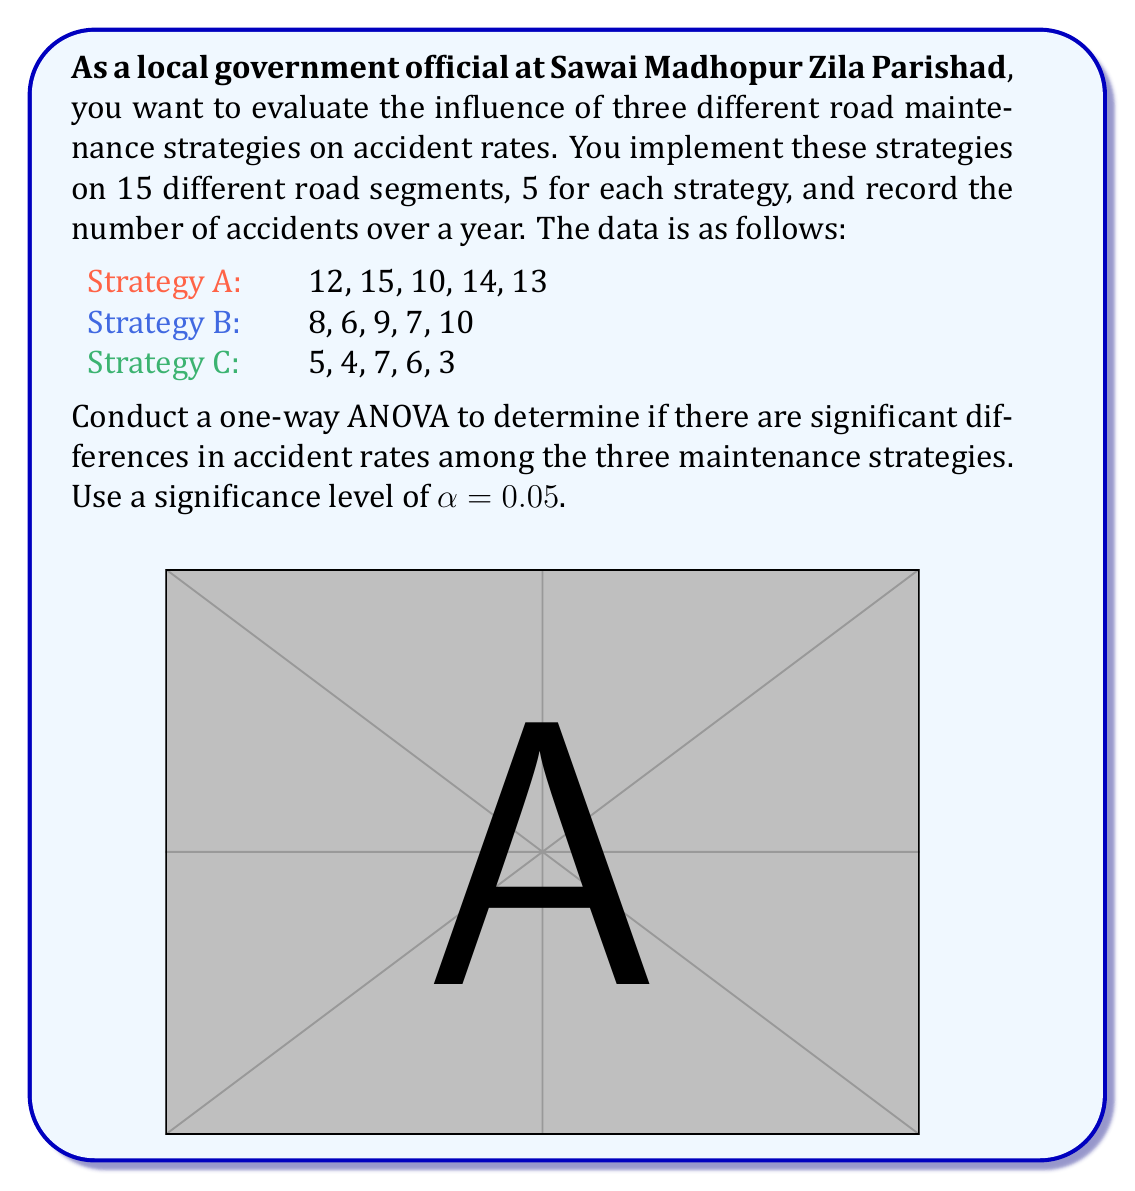Could you help me with this problem? To conduct a one-way ANOVA, we need to follow these steps:

1. Calculate the sum of squares between groups (SSB), within groups (SSW), and total (SST).
2. Calculate the degrees of freedom for between groups (dfB), within groups (dfW), and total (dfT).
3. Calculate the mean squares between groups (MSB) and within groups (MSW).
4. Calculate the F-statistic.
5. Compare the F-statistic with the critical F-value.

Step 1: Calculate sums of squares

First, we need to calculate the grand mean:
$$ \bar{X} = \frac{12+15+10+14+13+8+6+9+7+10+5+4+7+6+3}{15} = 8.6 $$

Now, we can calculate SSB, SSW, and SST:

SSB = $$ n\sum_{i=1}^{k} (\bar{X_i} - \bar{X})^2 $$
    = $$ 5[(12.8 - 8.6)^2 + (8 - 8.6)^2 + (5 - 8.6)^2] = 190.4 $$

SSW = $$ \sum_{i=1}^{k} \sum_{j=1}^{n} (X_{ij} - \bar{X_i})^2 $$
    = $$ [(12-12.8)^2 + ... + (13-12.8)^2] + [(8-8)^2 + ... + (10-8)^2] + [(5-5)^2 + ... + (3-5)^2] $$
    = $$ 22.8 + 14 + 16 = 52.8 $$

SST = SSB + SSW = 190.4 + 52.8 = 243.2

Step 2: Calculate degrees of freedom

dfB = k - 1 = 3 - 1 = 2
dfW = N - k = 15 - 3 = 12
dfT = N - 1 = 15 - 1 = 14

Step 3: Calculate mean squares

MSB = SSB / dfB = 190.4 / 2 = 95.2
MSW = SSW / dfW = 52.8 / 12 = 4.4

Step 4: Calculate F-statistic

$$ F = \frac{MSB}{MSW} = \frac{95.2}{4.4} = 21.64 $$

Step 5: Compare F-statistic with critical F-value

For α = 0.05, dfB = 2, and dfW = 12, the critical F-value is approximately 3.89.

Since our calculated F-statistic (21.64) is greater than the critical F-value (3.89), we reject the null hypothesis.
Answer: F(2,12) = 21.64, p < 0.05. Significant differences exist among the three road maintenance strategies. 